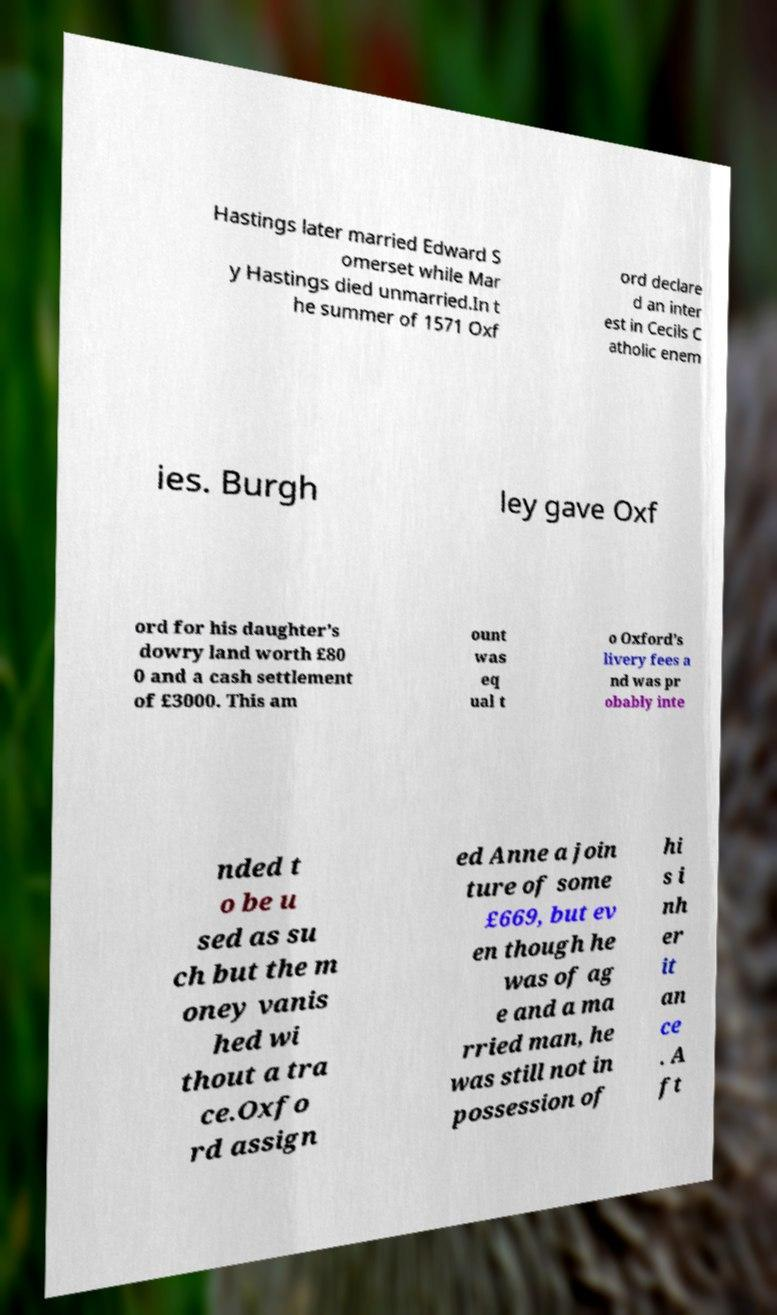There's text embedded in this image that I need extracted. Can you transcribe it verbatim? Hastings later married Edward S omerset while Mar y Hastings died unmarried.In t he summer of 1571 Oxf ord declare d an inter est in Cecils C atholic enem ies. Burgh ley gave Oxf ord for his daughter’s dowry land worth £80 0 and a cash settlement of £3000. This am ount was eq ual t o Oxford’s livery fees a nd was pr obably inte nded t o be u sed as su ch but the m oney vanis hed wi thout a tra ce.Oxfo rd assign ed Anne a join ture of some £669, but ev en though he was of ag e and a ma rried man, he was still not in possession of hi s i nh er it an ce . A ft 